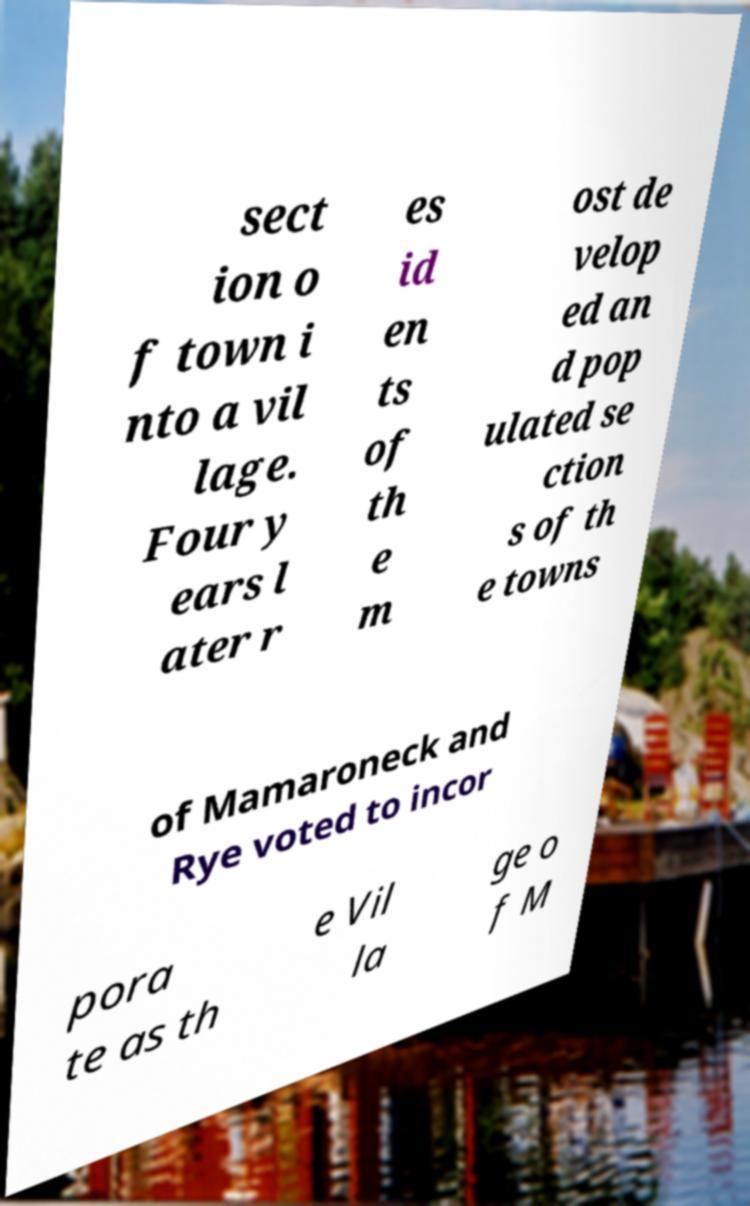Can you read and provide the text displayed in the image?This photo seems to have some interesting text. Can you extract and type it out for me? sect ion o f town i nto a vil lage. Four y ears l ater r es id en ts of th e m ost de velop ed an d pop ulated se ction s of th e towns of Mamaroneck and Rye voted to incor pora te as th e Vil la ge o f M 